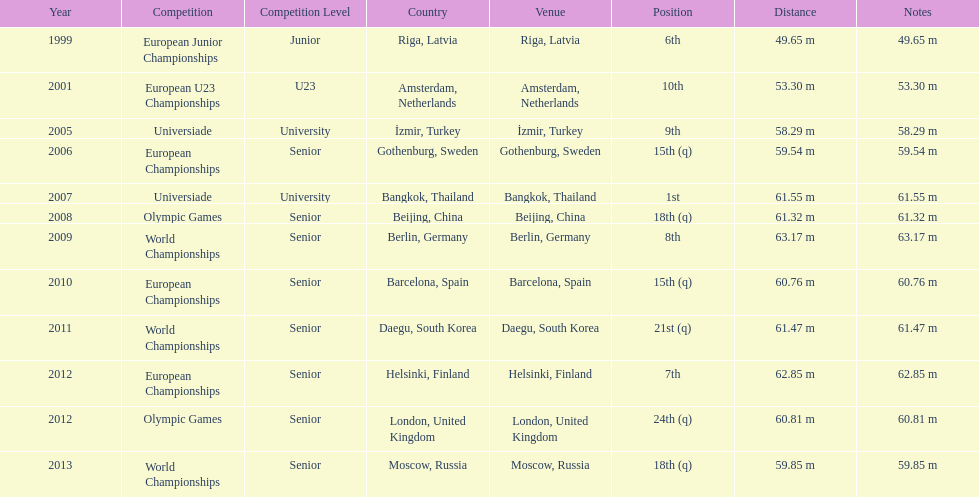30 meters? 2001. 